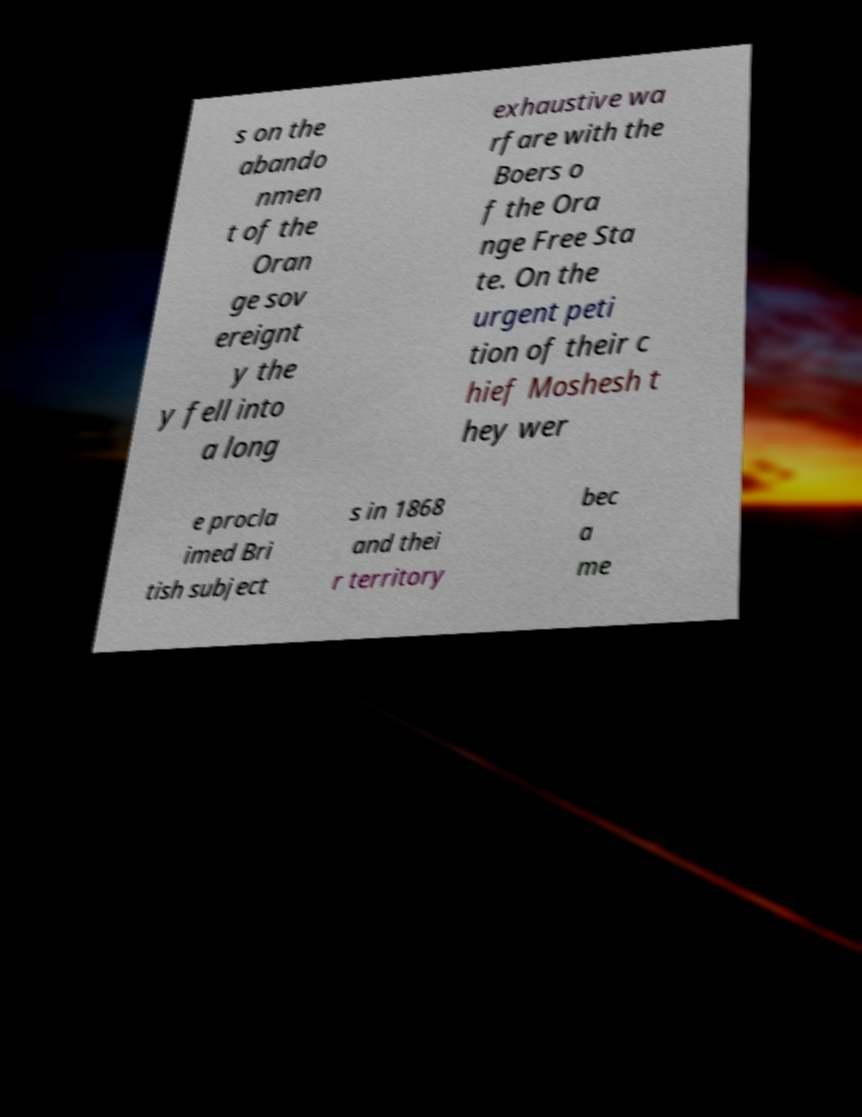Can you read and provide the text displayed in the image?This photo seems to have some interesting text. Can you extract and type it out for me? s on the abando nmen t of the Oran ge sov ereignt y the y fell into a long exhaustive wa rfare with the Boers o f the Ora nge Free Sta te. On the urgent peti tion of their c hief Moshesh t hey wer e procla imed Bri tish subject s in 1868 and thei r territory bec a me 